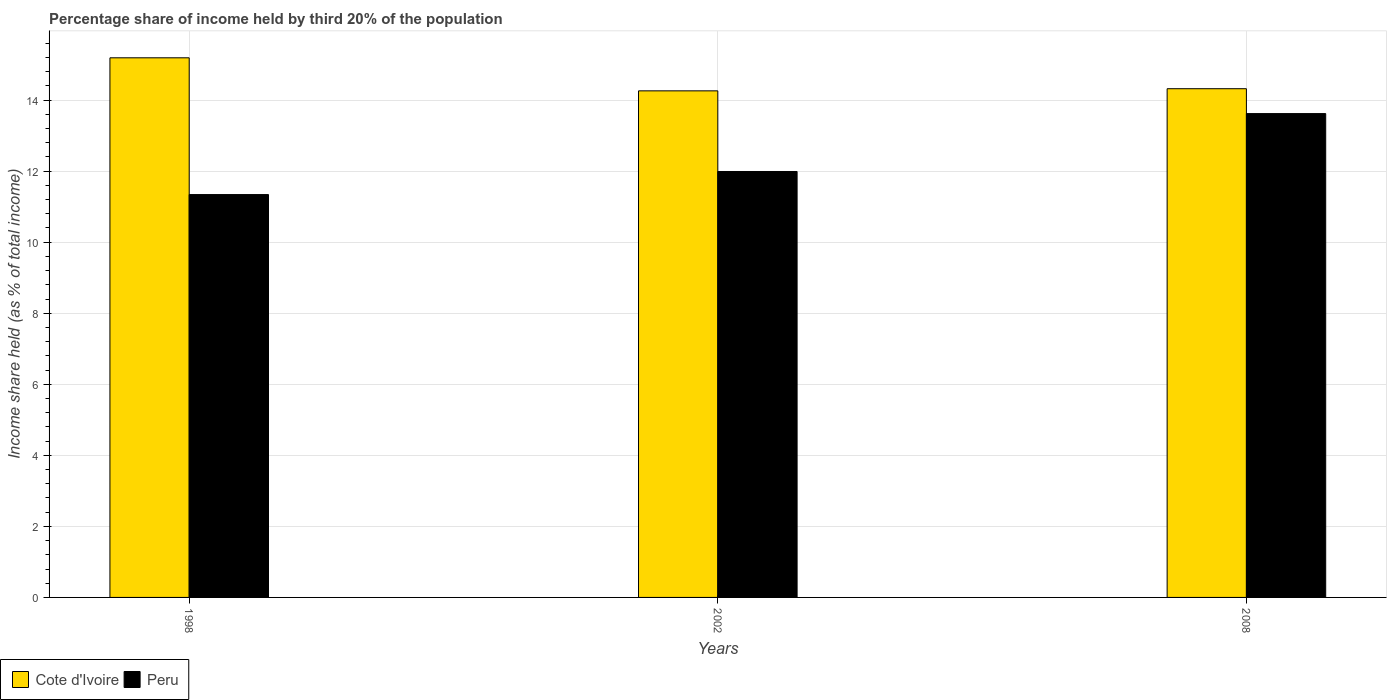Are the number of bars per tick equal to the number of legend labels?
Your response must be concise. Yes. Are the number of bars on each tick of the X-axis equal?
Offer a terse response. Yes. How many bars are there on the 3rd tick from the left?
Ensure brevity in your answer.  2. How many bars are there on the 2nd tick from the right?
Give a very brief answer. 2. What is the share of income held by third 20% of the population in Cote d'Ivoire in 2008?
Provide a succinct answer. 14.32. Across all years, what is the maximum share of income held by third 20% of the population in Peru?
Ensure brevity in your answer.  13.62. Across all years, what is the minimum share of income held by third 20% of the population in Cote d'Ivoire?
Offer a very short reply. 14.26. In which year was the share of income held by third 20% of the population in Peru maximum?
Your answer should be very brief. 2008. In which year was the share of income held by third 20% of the population in Peru minimum?
Provide a short and direct response. 1998. What is the total share of income held by third 20% of the population in Cote d'Ivoire in the graph?
Keep it short and to the point. 43.77. What is the difference between the share of income held by third 20% of the population in Cote d'Ivoire in 1998 and that in 2008?
Your answer should be very brief. 0.87. What is the difference between the share of income held by third 20% of the population in Peru in 2008 and the share of income held by third 20% of the population in Cote d'Ivoire in 1998?
Your answer should be very brief. -1.57. What is the average share of income held by third 20% of the population in Peru per year?
Make the answer very short. 12.32. In the year 2002, what is the difference between the share of income held by third 20% of the population in Cote d'Ivoire and share of income held by third 20% of the population in Peru?
Offer a terse response. 2.27. What is the ratio of the share of income held by third 20% of the population in Cote d'Ivoire in 2002 to that in 2008?
Make the answer very short. 1. Is the share of income held by third 20% of the population in Cote d'Ivoire in 1998 less than that in 2008?
Your answer should be compact. No. What is the difference between the highest and the second highest share of income held by third 20% of the population in Peru?
Give a very brief answer. 1.63. What is the difference between the highest and the lowest share of income held by third 20% of the population in Cote d'Ivoire?
Offer a very short reply. 0.93. In how many years, is the share of income held by third 20% of the population in Cote d'Ivoire greater than the average share of income held by third 20% of the population in Cote d'Ivoire taken over all years?
Give a very brief answer. 1. Is the sum of the share of income held by third 20% of the population in Cote d'Ivoire in 1998 and 2002 greater than the maximum share of income held by third 20% of the population in Peru across all years?
Your answer should be compact. Yes. What does the 2nd bar from the left in 2002 represents?
Provide a short and direct response. Peru. Are all the bars in the graph horizontal?
Make the answer very short. No. Are the values on the major ticks of Y-axis written in scientific E-notation?
Make the answer very short. No. Does the graph contain any zero values?
Your answer should be very brief. No. How are the legend labels stacked?
Ensure brevity in your answer.  Horizontal. What is the title of the graph?
Provide a short and direct response. Percentage share of income held by third 20% of the population. What is the label or title of the Y-axis?
Offer a very short reply. Income share held (as % of total income). What is the Income share held (as % of total income) of Cote d'Ivoire in 1998?
Ensure brevity in your answer.  15.19. What is the Income share held (as % of total income) of Peru in 1998?
Provide a short and direct response. 11.34. What is the Income share held (as % of total income) of Cote d'Ivoire in 2002?
Provide a succinct answer. 14.26. What is the Income share held (as % of total income) of Peru in 2002?
Provide a succinct answer. 11.99. What is the Income share held (as % of total income) of Cote d'Ivoire in 2008?
Provide a succinct answer. 14.32. What is the Income share held (as % of total income) in Peru in 2008?
Give a very brief answer. 13.62. Across all years, what is the maximum Income share held (as % of total income) in Cote d'Ivoire?
Offer a terse response. 15.19. Across all years, what is the maximum Income share held (as % of total income) of Peru?
Offer a terse response. 13.62. Across all years, what is the minimum Income share held (as % of total income) of Cote d'Ivoire?
Offer a terse response. 14.26. Across all years, what is the minimum Income share held (as % of total income) of Peru?
Provide a succinct answer. 11.34. What is the total Income share held (as % of total income) of Cote d'Ivoire in the graph?
Give a very brief answer. 43.77. What is the total Income share held (as % of total income) of Peru in the graph?
Keep it short and to the point. 36.95. What is the difference between the Income share held (as % of total income) of Cote d'Ivoire in 1998 and that in 2002?
Provide a short and direct response. 0.93. What is the difference between the Income share held (as % of total income) in Peru in 1998 and that in 2002?
Offer a very short reply. -0.65. What is the difference between the Income share held (as % of total income) of Cote d'Ivoire in 1998 and that in 2008?
Make the answer very short. 0.87. What is the difference between the Income share held (as % of total income) of Peru in 1998 and that in 2008?
Offer a terse response. -2.28. What is the difference between the Income share held (as % of total income) in Cote d'Ivoire in 2002 and that in 2008?
Your answer should be very brief. -0.06. What is the difference between the Income share held (as % of total income) of Peru in 2002 and that in 2008?
Provide a short and direct response. -1.63. What is the difference between the Income share held (as % of total income) in Cote d'Ivoire in 1998 and the Income share held (as % of total income) in Peru in 2002?
Ensure brevity in your answer.  3.2. What is the difference between the Income share held (as % of total income) in Cote d'Ivoire in 1998 and the Income share held (as % of total income) in Peru in 2008?
Your answer should be very brief. 1.57. What is the difference between the Income share held (as % of total income) of Cote d'Ivoire in 2002 and the Income share held (as % of total income) of Peru in 2008?
Provide a short and direct response. 0.64. What is the average Income share held (as % of total income) in Cote d'Ivoire per year?
Your answer should be very brief. 14.59. What is the average Income share held (as % of total income) of Peru per year?
Make the answer very short. 12.32. In the year 1998, what is the difference between the Income share held (as % of total income) of Cote d'Ivoire and Income share held (as % of total income) of Peru?
Offer a terse response. 3.85. In the year 2002, what is the difference between the Income share held (as % of total income) of Cote d'Ivoire and Income share held (as % of total income) of Peru?
Provide a short and direct response. 2.27. In the year 2008, what is the difference between the Income share held (as % of total income) of Cote d'Ivoire and Income share held (as % of total income) of Peru?
Make the answer very short. 0.7. What is the ratio of the Income share held (as % of total income) of Cote d'Ivoire in 1998 to that in 2002?
Your answer should be very brief. 1.07. What is the ratio of the Income share held (as % of total income) of Peru in 1998 to that in 2002?
Provide a succinct answer. 0.95. What is the ratio of the Income share held (as % of total income) of Cote d'Ivoire in 1998 to that in 2008?
Your answer should be very brief. 1.06. What is the ratio of the Income share held (as % of total income) in Peru in 1998 to that in 2008?
Offer a very short reply. 0.83. What is the ratio of the Income share held (as % of total income) in Peru in 2002 to that in 2008?
Ensure brevity in your answer.  0.88. What is the difference between the highest and the second highest Income share held (as % of total income) in Cote d'Ivoire?
Keep it short and to the point. 0.87. What is the difference between the highest and the second highest Income share held (as % of total income) in Peru?
Ensure brevity in your answer.  1.63. What is the difference between the highest and the lowest Income share held (as % of total income) in Cote d'Ivoire?
Make the answer very short. 0.93. What is the difference between the highest and the lowest Income share held (as % of total income) of Peru?
Your answer should be very brief. 2.28. 